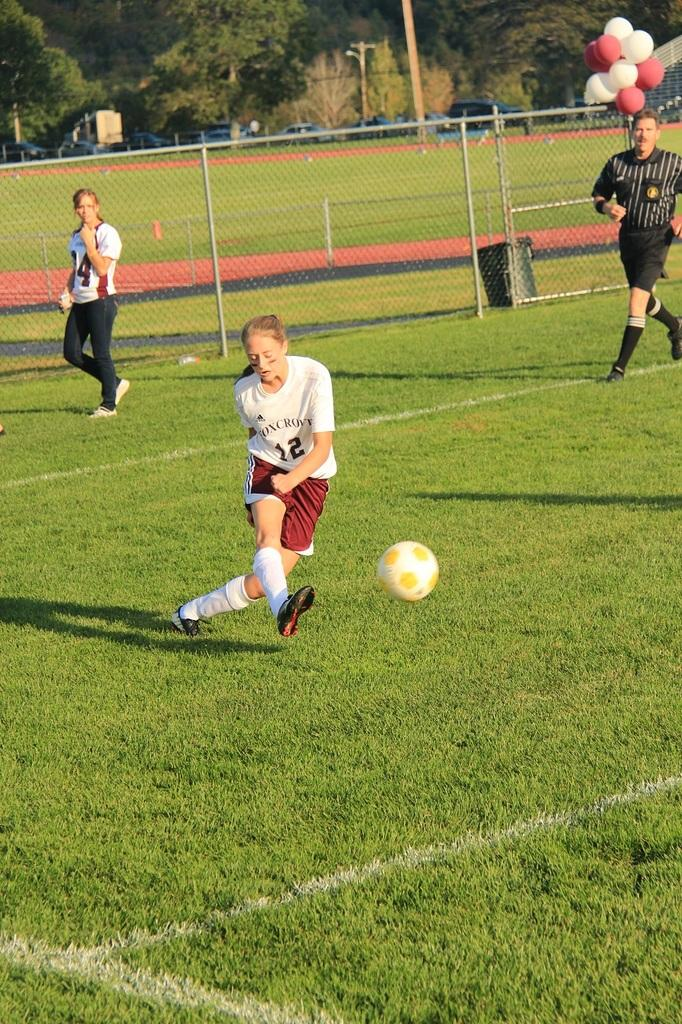<image>
Summarize the visual content of the image. Soccer player number 12 kicks the soccer ball near the corner of the field. 